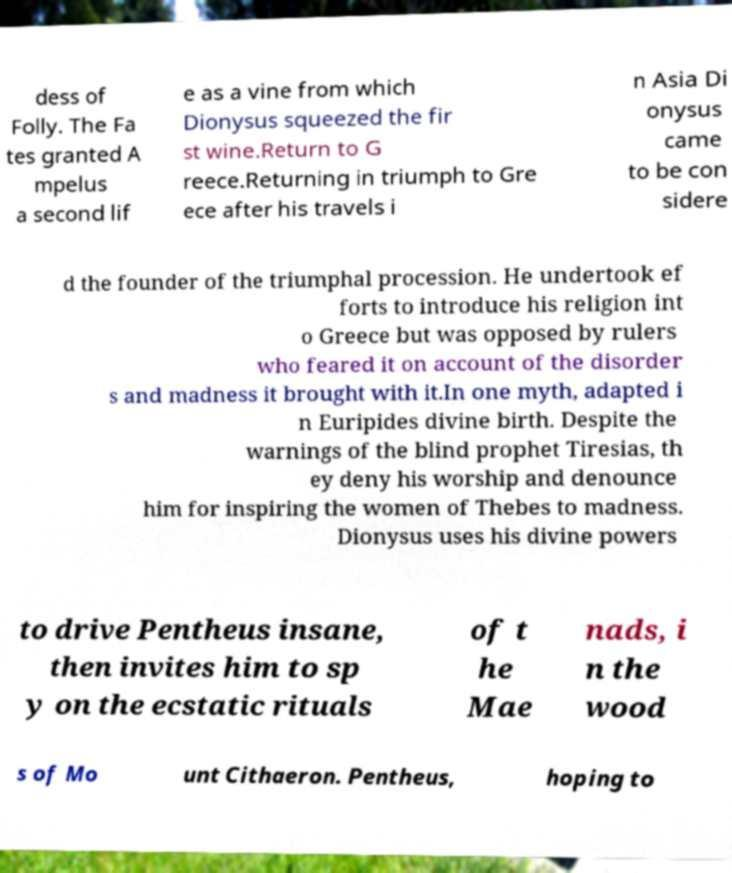There's text embedded in this image that I need extracted. Can you transcribe it verbatim? dess of Folly. The Fa tes granted A mpelus a second lif e as a vine from which Dionysus squeezed the fir st wine.Return to G reece.Returning in triumph to Gre ece after his travels i n Asia Di onysus came to be con sidere d the founder of the triumphal procession. He undertook ef forts to introduce his religion int o Greece but was opposed by rulers who feared it on account of the disorder s and madness it brought with it.In one myth, adapted i n Euripides divine birth. Despite the warnings of the blind prophet Tiresias, th ey deny his worship and denounce him for inspiring the women of Thebes to madness. Dionysus uses his divine powers to drive Pentheus insane, then invites him to sp y on the ecstatic rituals of t he Mae nads, i n the wood s of Mo unt Cithaeron. Pentheus, hoping to 